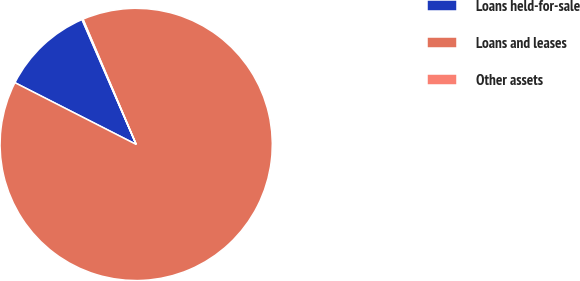Convert chart. <chart><loc_0><loc_0><loc_500><loc_500><pie_chart><fcel>Loans held-for-sale<fcel>Loans and leases<fcel>Other assets<nl><fcel>10.99%<fcel>88.89%<fcel>0.12%<nl></chart> 